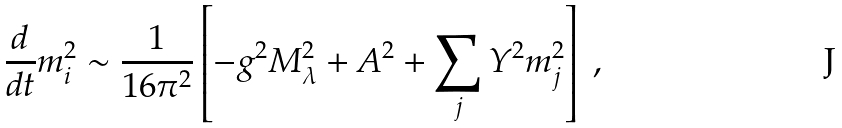<formula> <loc_0><loc_0><loc_500><loc_500>\frac { d } { d t } m ^ { 2 } _ { i } \sim \frac { 1 } { 1 6 \pi ^ { 2 } } \left [ - g ^ { 2 } M _ { \lambda } ^ { 2 } + A ^ { 2 } + \sum _ { j } Y ^ { 2 } m _ { j } ^ { 2 } \right ] \ ,</formula> 